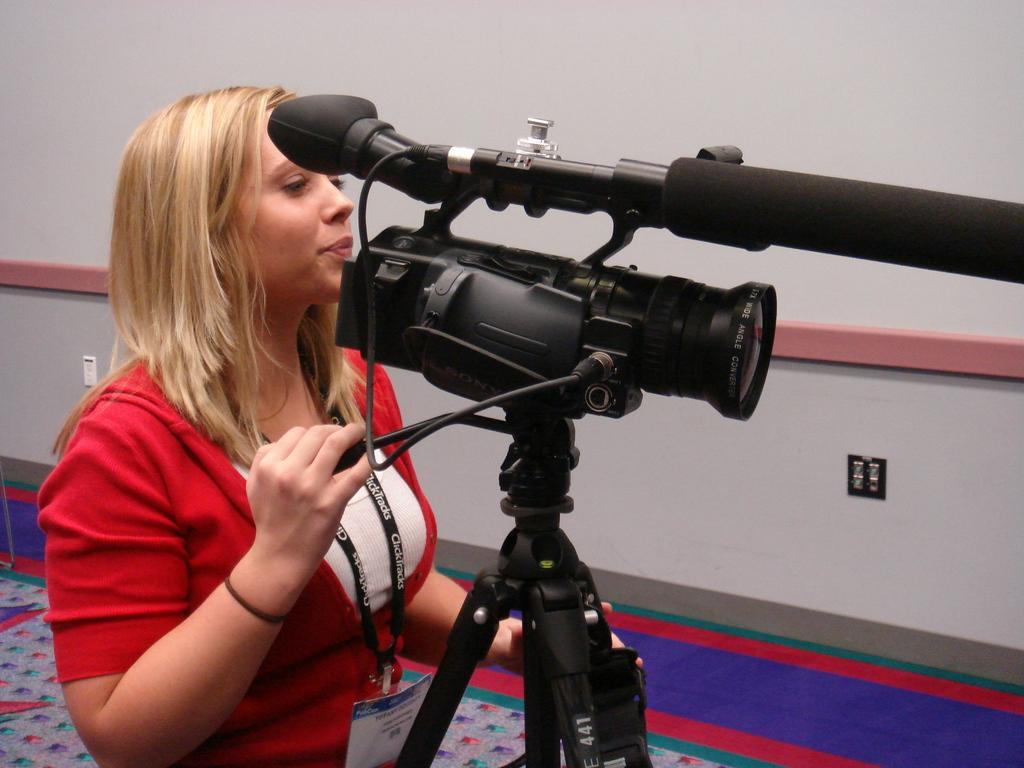How would you summarize this image in a sentence or two? In this picture we can see a woman handling a video camera, in the background there is a wall, in the bottom there is a mat, she wore identity card. 